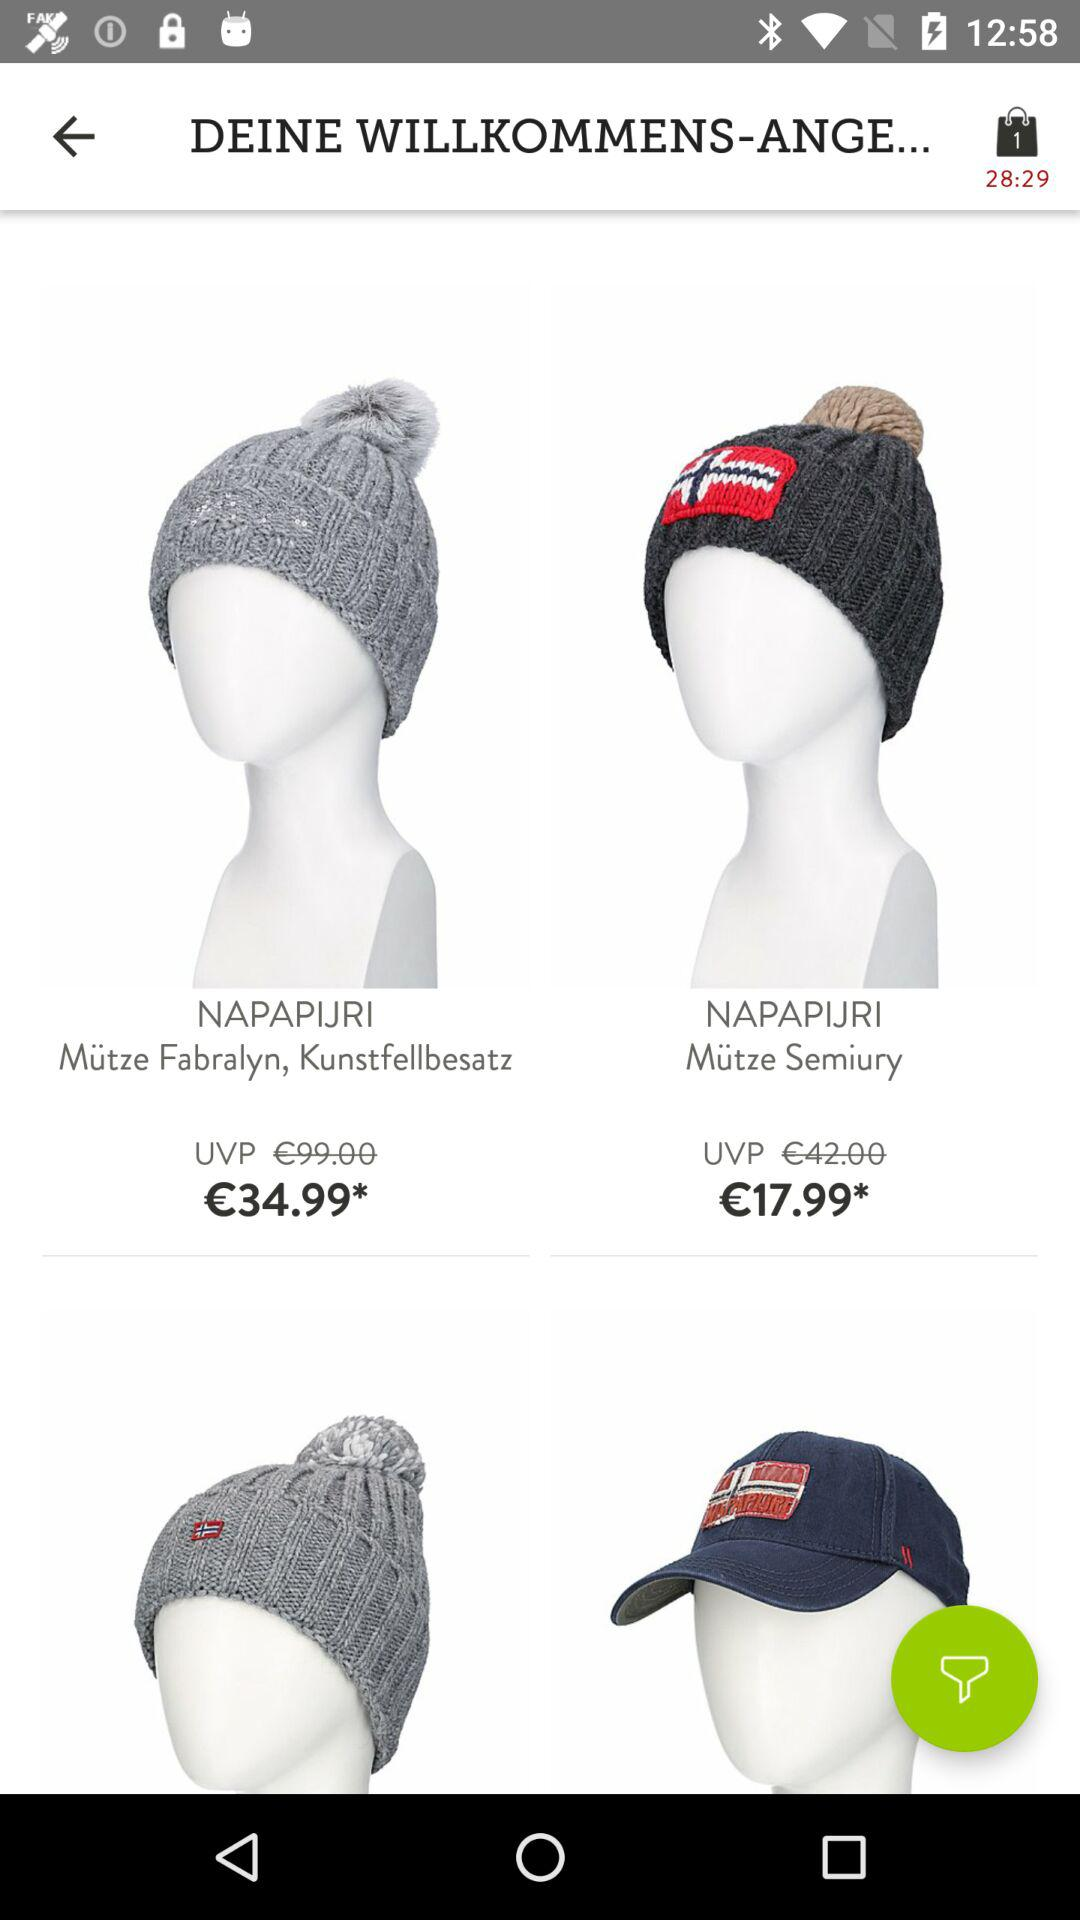What is the remaining time? The remaining time is 28 minutes 29 seconds. 